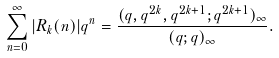Convert formula to latex. <formula><loc_0><loc_0><loc_500><loc_500>\sum _ { n = 0 } ^ { \infty } | R _ { k } ( n ) | q ^ { n } = \frac { ( q , q ^ { 2 k } , q ^ { 2 k + 1 } ; q ^ { 2 k + 1 } ) _ { \infty } } { ( q ; q ) _ { \infty } } .</formula> 